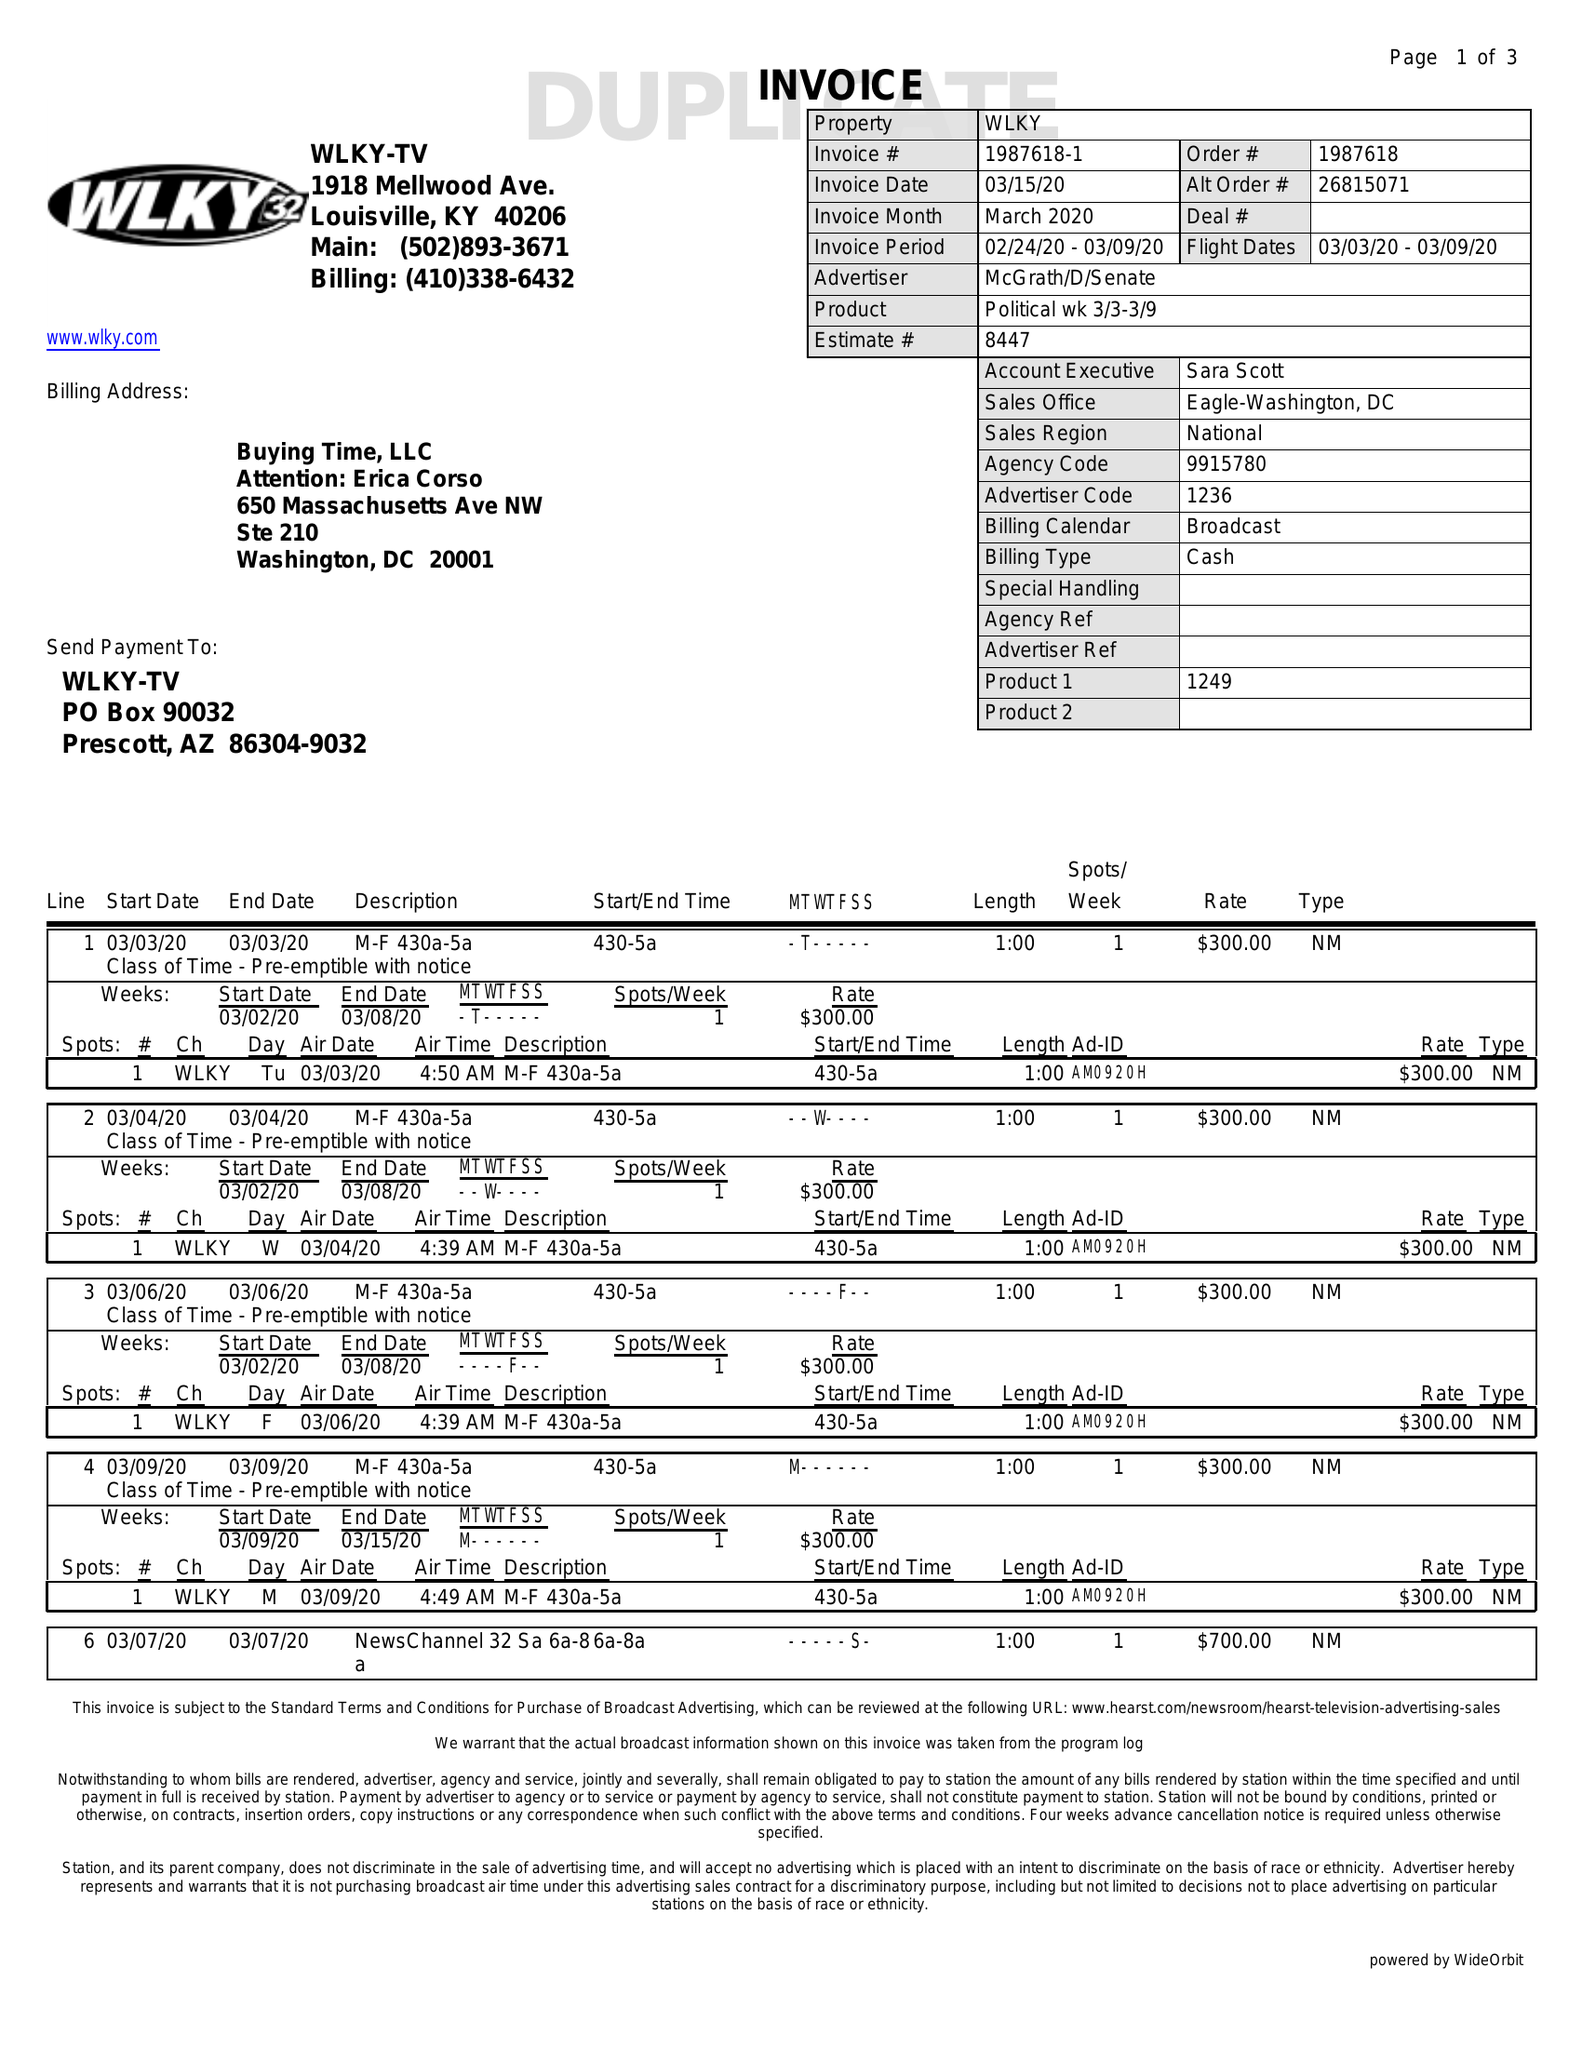What is the value for the flight_from?
Answer the question using a single word or phrase. 03/03/20 